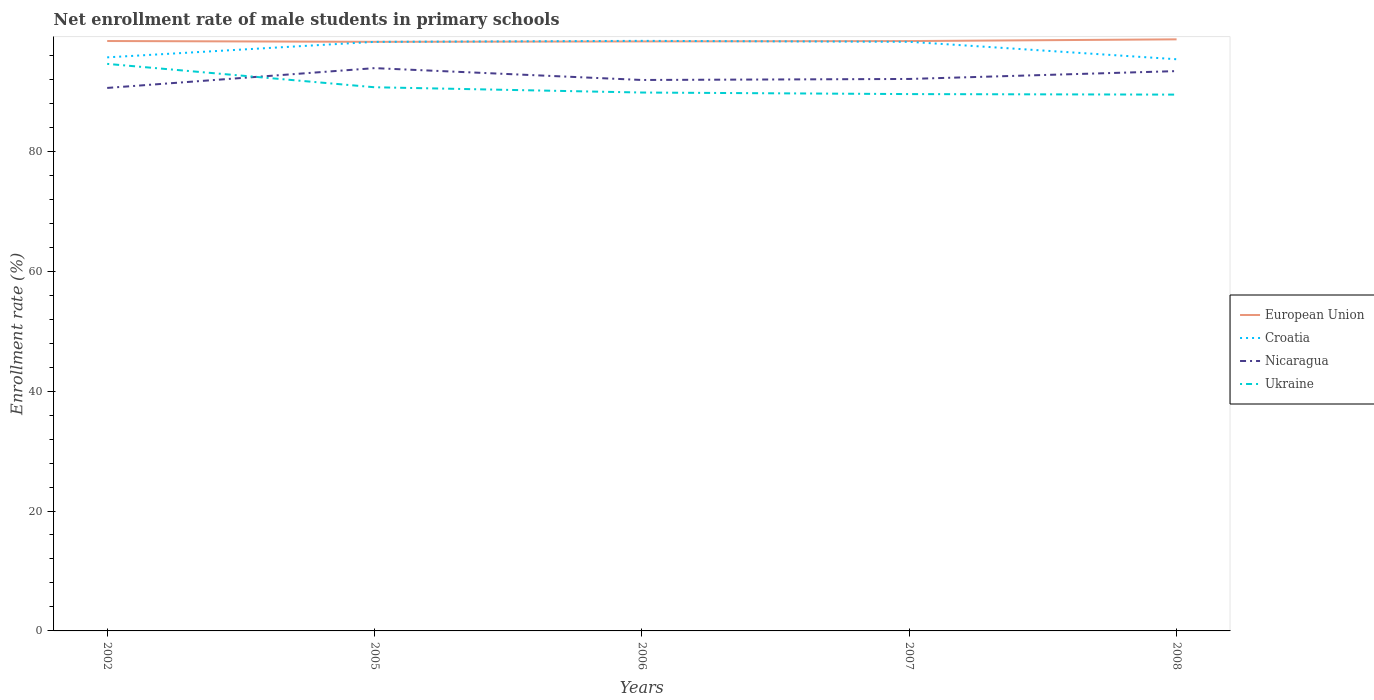Across all years, what is the maximum net enrollment rate of male students in primary schools in Croatia?
Provide a succinct answer. 95.35. What is the total net enrollment rate of male students in primary schools in Ukraine in the graph?
Your answer should be very brief. 0.09. What is the difference between the highest and the second highest net enrollment rate of male students in primary schools in European Union?
Your response must be concise. 0.42. How many years are there in the graph?
Give a very brief answer. 5. Are the values on the major ticks of Y-axis written in scientific E-notation?
Your answer should be very brief. No. Does the graph contain grids?
Your response must be concise. No. Where does the legend appear in the graph?
Offer a terse response. Center right. How many legend labels are there?
Your answer should be compact. 4. How are the legend labels stacked?
Keep it short and to the point. Vertical. What is the title of the graph?
Your answer should be very brief. Net enrollment rate of male students in primary schools. What is the label or title of the Y-axis?
Ensure brevity in your answer.  Enrollment rate (%). What is the Enrollment rate (%) of European Union in 2002?
Provide a succinct answer. 98.39. What is the Enrollment rate (%) of Croatia in 2002?
Ensure brevity in your answer.  95.66. What is the Enrollment rate (%) of Nicaragua in 2002?
Offer a very short reply. 90.56. What is the Enrollment rate (%) of Ukraine in 2002?
Your answer should be very brief. 94.58. What is the Enrollment rate (%) in European Union in 2005?
Give a very brief answer. 98.25. What is the Enrollment rate (%) in Croatia in 2005?
Make the answer very short. 98.25. What is the Enrollment rate (%) of Nicaragua in 2005?
Make the answer very short. 93.87. What is the Enrollment rate (%) in Ukraine in 2005?
Offer a terse response. 90.68. What is the Enrollment rate (%) in European Union in 2006?
Your answer should be compact. 98.32. What is the Enrollment rate (%) of Croatia in 2006?
Your answer should be very brief. 98.42. What is the Enrollment rate (%) in Nicaragua in 2006?
Give a very brief answer. 91.89. What is the Enrollment rate (%) in Ukraine in 2006?
Ensure brevity in your answer.  89.8. What is the Enrollment rate (%) of European Union in 2007?
Your response must be concise. 98.38. What is the Enrollment rate (%) in Croatia in 2007?
Ensure brevity in your answer.  98.26. What is the Enrollment rate (%) of Nicaragua in 2007?
Make the answer very short. 92.06. What is the Enrollment rate (%) of Ukraine in 2007?
Your answer should be very brief. 89.54. What is the Enrollment rate (%) of European Union in 2008?
Keep it short and to the point. 98.67. What is the Enrollment rate (%) in Croatia in 2008?
Offer a terse response. 95.35. What is the Enrollment rate (%) in Nicaragua in 2008?
Ensure brevity in your answer.  93.37. What is the Enrollment rate (%) of Ukraine in 2008?
Provide a short and direct response. 89.45. Across all years, what is the maximum Enrollment rate (%) in European Union?
Make the answer very short. 98.67. Across all years, what is the maximum Enrollment rate (%) of Croatia?
Make the answer very short. 98.42. Across all years, what is the maximum Enrollment rate (%) in Nicaragua?
Your answer should be very brief. 93.87. Across all years, what is the maximum Enrollment rate (%) in Ukraine?
Your answer should be very brief. 94.58. Across all years, what is the minimum Enrollment rate (%) of European Union?
Give a very brief answer. 98.25. Across all years, what is the minimum Enrollment rate (%) of Croatia?
Keep it short and to the point. 95.35. Across all years, what is the minimum Enrollment rate (%) in Nicaragua?
Your answer should be compact. 90.56. Across all years, what is the minimum Enrollment rate (%) in Ukraine?
Offer a terse response. 89.45. What is the total Enrollment rate (%) in European Union in the graph?
Provide a short and direct response. 492.01. What is the total Enrollment rate (%) in Croatia in the graph?
Provide a short and direct response. 485.94. What is the total Enrollment rate (%) in Nicaragua in the graph?
Offer a terse response. 461.76. What is the total Enrollment rate (%) in Ukraine in the graph?
Make the answer very short. 454.04. What is the difference between the Enrollment rate (%) of European Union in 2002 and that in 2005?
Provide a succinct answer. 0.14. What is the difference between the Enrollment rate (%) in Croatia in 2002 and that in 2005?
Make the answer very short. -2.59. What is the difference between the Enrollment rate (%) in Nicaragua in 2002 and that in 2005?
Ensure brevity in your answer.  -3.3. What is the difference between the Enrollment rate (%) of Ukraine in 2002 and that in 2005?
Provide a short and direct response. 3.9. What is the difference between the Enrollment rate (%) in European Union in 2002 and that in 2006?
Give a very brief answer. 0.07. What is the difference between the Enrollment rate (%) of Croatia in 2002 and that in 2006?
Provide a short and direct response. -2.75. What is the difference between the Enrollment rate (%) of Nicaragua in 2002 and that in 2006?
Offer a terse response. -1.33. What is the difference between the Enrollment rate (%) of Ukraine in 2002 and that in 2006?
Your answer should be very brief. 4.78. What is the difference between the Enrollment rate (%) in European Union in 2002 and that in 2007?
Your answer should be compact. 0.01. What is the difference between the Enrollment rate (%) of Croatia in 2002 and that in 2007?
Offer a very short reply. -2.59. What is the difference between the Enrollment rate (%) of Nicaragua in 2002 and that in 2007?
Give a very brief answer. -1.5. What is the difference between the Enrollment rate (%) of Ukraine in 2002 and that in 2007?
Your answer should be very brief. 5.04. What is the difference between the Enrollment rate (%) of European Union in 2002 and that in 2008?
Your response must be concise. -0.28. What is the difference between the Enrollment rate (%) of Croatia in 2002 and that in 2008?
Ensure brevity in your answer.  0.31. What is the difference between the Enrollment rate (%) in Nicaragua in 2002 and that in 2008?
Offer a very short reply. -2.81. What is the difference between the Enrollment rate (%) in Ukraine in 2002 and that in 2008?
Provide a succinct answer. 5.13. What is the difference between the Enrollment rate (%) in European Union in 2005 and that in 2006?
Your answer should be very brief. -0.07. What is the difference between the Enrollment rate (%) in Croatia in 2005 and that in 2006?
Offer a very short reply. -0.17. What is the difference between the Enrollment rate (%) of Nicaragua in 2005 and that in 2006?
Your answer should be very brief. 1.98. What is the difference between the Enrollment rate (%) in European Union in 2005 and that in 2007?
Make the answer very short. -0.13. What is the difference between the Enrollment rate (%) of Croatia in 2005 and that in 2007?
Keep it short and to the point. -0.01. What is the difference between the Enrollment rate (%) in Nicaragua in 2005 and that in 2007?
Your response must be concise. 1.81. What is the difference between the Enrollment rate (%) of Ukraine in 2005 and that in 2007?
Offer a very short reply. 1.14. What is the difference between the Enrollment rate (%) in European Union in 2005 and that in 2008?
Provide a short and direct response. -0.42. What is the difference between the Enrollment rate (%) in Croatia in 2005 and that in 2008?
Your answer should be compact. 2.9. What is the difference between the Enrollment rate (%) in Nicaragua in 2005 and that in 2008?
Your answer should be very brief. 0.5. What is the difference between the Enrollment rate (%) in Ukraine in 2005 and that in 2008?
Offer a very short reply. 1.23. What is the difference between the Enrollment rate (%) in European Union in 2006 and that in 2007?
Provide a short and direct response. -0.06. What is the difference between the Enrollment rate (%) of Croatia in 2006 and that in 2007?
Your answer should be compact. 0.16. What is the difference between the Enrollment rate (%) in Nicaragua in 2006 and that in 2007?
Your answer should be compact. -0.17. What is the difference between the Enrollment rate (%) of Ukraine in 2006 and that in 2007?
Your response must be concise. 0.26. What is the difference between the Enrollment rate (%) in European Union in 2006 and that in 2008?
Your answer should be very brief. -0.35. What is the difference between the Enrollment rate (%) in Croatia in 2006 and that in 2008?
Offer a terse response. 3.07. What is the difference between the Enrollment rate (%) in Nicaragua in 2006 and that in 2008?
Give a very brief answer. -1.48. What is the difference between the Enrollment rate (%) of Ukraine in 2006 and that in 2008?
Offer a terse response. 0.35. What is the difference between the Enrollment rate (%) of European Union in 2007 and that in 2008?
Ensure brevity in your answer.  -0.29. What is the difference between the Enrollment rate (%) of Croatia in 2007 and that in 2008?
Keep it short and to the point. 2.91. What is the difference between the Enrollment rate (%) of Nicaragua in 2007 and that in 2008?
Provide a succinct answer. -1.31. What is the difference between the Enrollment rate (%) in Ukraine in 2007 and that in 2008?
Give a very brief answer. 0.09. What is the difference between the Enrollment rate (%) in European Union in 2002 and the Enrollment rate (%) in Croatia in 2005?
Make the answer very short. 0.14. What is the difference between the Enrollment rate (%) in European Union in 2002 and the Enrollment rate (%) in Nicaragua in 2005?
Offer a very short reply. 4.52. What is the difference between the Enrollment rate (%) of European Union in 2002 and the Enrollment rate (%) of Ukraine in 2005?
Provide a short and direct response. 7.71. What is the difference between the Enrollment rate (%) in Croatia in 2002 and the Enrollment rate (%) in Nicaragua in 2005?
Your answer should be compact. 1.8. What is the difference between the Enrollment rate (%) of Croatia in 2002 and the Enrollment rate (%) of Ukraine in 2005?
Make the answer very short. 4.99. What is the difference between the Enrollment rate (%) in Nicaragua in 2002 and the Enrollment rate (%) in Ukraine in 2005?
Provide a succinct answer. -0.11. What is the difference between the Enrollment rate (%) of European Union in 2002 and the Enrollment rate (%) of Croatia in 2006?
Make the answer very short. -0.03. What is the difference between the Enrollment rate (%) in European Union in 2002 and the Enrollment rate (%) in Nicaragua in 2006?
Offer a terse response. 6.5. What is the difference between the Enrollment rate (%) in European Union in 2002 and the Enrollment rate (%) in Ukraine in 2006?
Keep it short and to the point. 8.59. What is the difference between the Enrollment rate (%) in Croatia in 2002 and the Enrollment rate (%) in Nicaragua in 2006?
Keep it short and to the point. 3.77. What is the difference between the Enrollment rate (%) in Croatia in 2002 and the Enrollment rate (%) in Ukraine in 2006?
Keep it short and to the point. 5.87. What is the difference between the Enrollment rate (%) of Nicaragua in 2002 and the Enrollment rate (%) of Ukraine in 2006?
Give a very brief answer. 0.77. What is the difference between the Enrollment rate (%) in European Union in 2002 and the Enrollment rate (%) in Croatia in 2007?
Your answer should be compact. 0.13. What is the difference between the Enrollment rate (%) in European Union in 2002 and the Enrollment rate (%) in Nicaragua in 2007?
Ensure brevity in your answer.  6.33. What is the difference between the Enrollment rate (%) in European Union in 2002 and the Enrollment rate (%) in Ukraine in 2007?
Provide a short and direct response. 8.85. What is the difference between the Enrollment rate (%) of Croatia in 2002 and the Enrollment rate (%) of Nicaragua in 2007?
Provide a short and direct response. 3.6. What is the difference between the Enrollment rate (%) of Croatia in 2002 and the Enrollment rate (%) of Ukraine in 2007?
Provide a succinct answer. 6.13. What is the difference between the Enrollment rate (%) of Nicaragua in 2002 and the Enrollment rate (%) of Ukraine in 2007?
Your response must be concise. 1.03. What is the difference between the Enrollment rate (%) in European Union in 2002 and the Enrollment rate (%) in Croatia in 2008?
Your answer should be compact. 3.04. What is the difference between the Enrollment rate (%) in European Union in 2002 and the Enrollment rate (%) in Nicaragua in 2008?
Ensure brevity in your answer.  5.02. What is the difference between the Enrollment rate (%) of European Union in 2002 and the Enrollment rate (%) of Ukraine in 2008?
Your response must be concise. 8.94. What is the difference between the Enrollment rate (%) of Croatia in 2002 and the Enrollment rate (%) of Nicaragua in 2008?
Provide a succinct answer. 2.29. What is the difference between the Enrollment rate (%) in Croatia in 2002 and the Enrollment rate (%) in Ukraine in 2008?
Make the answer very short. 6.21. What is the difference between the Enrollment rate (%) of Nicaragua in 2002 and the Enrollment rate (%) of Ukraine in 2008?
Your response must be concise. 1.11. What is the difference between the Enrollment rate (%) of European Union in 2005 and the Enrollment rate (%) of Croatia in 2006?
Give a very brief answer. -0.16. What is the difference between the Enrollment rate (%) in European Union in 2005 and the Enrollment rate (%) in Nicaragua in 2006?
Offer a very short reply. 6.36. What is the difference between the Enrollment rate (%) of European Union in 2005 and the Enrollment rate (%) of Ukraine in 2006?
Ensure brevity in your answer.  8.45. What is the difference between the Enrollment rate (%) of Croatia in 2005 and the Enrollment rate (%) of Nicaragua in 2006?
Ensure brevity in your answer.  6.36. What is the difference between the Enrollment rate (%) in Croatia in 2005 and the Enrollment rate (%) in Ukraine in 2006?
Provide a short and direct response. 8.45. What is the difference between the Enrollment rate (%) of Nicaragua in 2005 and the Enrollment rate (%) of Ukraine in 2006?
Give a very brief answer. 4.07. What is the difference between the Enrollment rate (%) of European Union in 2005 and the Enrollment rate (%) of Croatia in 2007?
Make the answer very short. -0. What is the difference between the Enrollment rate (%) of European Union in 2005 and the Enrollment rate (%) of Nicaragua in 2007?
Offer a terse response. 6.19. What is the difference between the Enrollment rate (%) in European Union in 2005 and the Enrollment rate (%) in Ukraine in 2007?
Your response must be concise. 8.72. What is the difference between the Enrollment rate (%) in Croatia in 2005 and the Enrollment rate (%) in Nicaragua in 2007?
Give a very brief answer. 6.19. What is the difference between the Enrollment rate (%) of Croatia in 2005 and the Enrollment rate (%) of Ukraine in 2007?
Provide a short and direct response. 8.71. What is the difference between the Enrollment rate (%) in Nicaragua in 2005 and the Enrollment rate (%) in Ukraine in 2007?
Make the answer very short. 4.33. What is the difference between the Enrollment rate (%) in European Union in 2005 and the Enrollment rate (%) in Croatia in 2008?
Your answer should be compact. 2.9. What is the difference between the Enrollment rate (%) in European Union in 2005 and the Enrollment rate (%) in Nicaragua in 2008?
Provide a succinct answer. 4.88. What is the difference between the Enrollment rate (%) in European Union in 2005 and the Enrollment rate (%) in Ukraine in 2008?
Keep it short and to the point. 8.8. What is the difference between the Enrollment rate (%) of Croatia in 2005 and the Enrollment rate (%) of Nicaragua in 2008?
Your response must be concise. 4.88. What is the difference between the Enrollment rate (%) of Croatia in 2005 and the Enrollment rate (%) of Ukraine in 2008?
Offer a terse response. 8.8. What is the difference between the Enrollment rate (%) of Nicaragua in 2005 and the Enrollment rate (%) of Ukraine in 2008?
Provide a succinct answer. 4.42. What is the difference between the Enrollment rate (%) in European Union in 2006 and the Enrollment rate (%) in Croatia in 2007?
Make the answer very short. 0.07. What is the difference between the Enrollment rate (%) in European Union in 2006 and the Enrollment rate (%) in Nicaragua in 2007?
Provide a succinct answer. 6.26. What is the difference between the Enrollment rate (%) of European Union in 2006 and the Enrollment rate (%) of Ukraine in 2007?
Your answer should be compact. 8.78. What is the difference between the Enrollment rate (%) of Croatia in 2006 and the Enrollment rate (%) of Nicaragua in 2007?
Your response must be concise. 6.35. What is the difference between the Enrollment rate (%) of Croatia in 2006 and the Enrollment rate (%) of Ukraine in 2007?
Provide a succinct answer. 8.88. What is the difference between the Enrollment rate (%) of Nicaragua in 2006 and the Enrollment rate (%) of Ukraine in 2007?
Your answer should be very brief. 2.35. What is the difference between the Enrollment rate (%) of European Union in 2006 and the Enrollment rate (%) of Croatia in 2008?
Give a very brief answer. 2.97. What is the difference between the Enrollment rate (%) of European Union in 2006 and the Enrollment rate (%) of Nicaragua in 2008?
Your answer should be compact. 4.95. What is the difference between the Enrollment rate (%) of European Union in 2006 and the Enrollment rate (%) of Ukraine in 2008?
Offer a terse response. 8.87. What is the difference between the Enrollment rate (%) in Croatia in 2006 and the Enrollment rate (%) in Nicaragua in 2008?
Make the answer very short. 5.04. What is the difference between the Enrollment rate (%) in Croatia in 2006 and the Enrollment rate (%) in Ukraine in 2008?
Your answer should be compact. 8.97. What is the difference between the Enrollment rate (%) in Nicaragua in 2006 and the Enrollment rate (%) in Ukraine in 2008?
Give a very brief answer. 2.44. What is the difference between the Enrollment rate (%) of European Union in 2007 and the Enrollment rate (%) of Croatia in 2008?
Your response must be concise. 3.03. What is the difference between the Enrollment rate (%) of European Union in 2007 and the Enrollment rate (%) of Nicaragua in 2008?
Give a very brief answer. 5.01. What is the difference between the Enrollment rate (%) in European Union in 2007 and the Enrollment rate (%) in Ukraine in 2008?
Offer a very short reply. 8.93. What is the difference between the Enrollment rate (%) of Croatia in 2007 and the Enrollment rate (%) of Nicaragua in 2008?
Make the answer very short. 4.89. What is the difference between the Enrollment rate (%) of Croatia in 2007 and the Enrollment rate (%) of Ukraine in 2008?
Your answer should be very brief. 8.81. What is the difference between the Enrollment rate (%) in Nicaragua in 2007 and the Enrollment rate (%) in Ukraine in 2008?
Offer a very short reply. 2.61. What is the average Enrollment rate (%) in European Union per year?
Provide a succinct answer. 98.4. What is the average Enrollment rate (%) of Croatia per year?
Keep it short and to the point. 97.19. What is the average Enrollment rate (%) in Nicaragua per year?
Offer a terse response. 92.35. What is the average Enrollment rate (%) in Ukraine per year?
Offer a very short reply. 90.81. In the year 2002, what is the difference between the Enrollment rate (%) of European Union and Enrollment rate (%) of Croatia?
Offer a terse response. 2.73. In the year 2002, what is the difference between the Enrollment rate (%) in European Union and Enrollment rate (%) in Nicaragua?
Make the answer very short. 7.83. In the year 2002, what is the difference between the Enrollment rate (%) in European Union and Enrollment rate (%) in Ukraine?
Provide a succinct answer. 3.81. In the year 2002, what is the difference between the Enrollment rate (%) in Croatia and Enrollment rate (%) in Ukraine?
Provide a short and direct response. 1.09. In the year 2002, what is the difference between the Enrollment rate (%) in Nicaragua and Enrollment rate (%) in Ukraine?
Ensure brevity in your answer.  -4.01. In the year 2005, what is the difference between the Enrollment rate (%) of European Union and Enrollment rate (%) of Croatia?
Provide a succinct answer. 0. In the year 2005, what is the difference between the Enrollment rate (%) of European Union and Enrollment rate (%) of Nicaragua?
Your answer should be very brief. 4.39. In the year 2005, what is the difference between the Enrollment rate (%) of European Union and Enrollment rate (%) of Ukraine?
Make the answer very short. 7.57. In the year 2005, what is the difference between the Enrollment rate (%) in Croatia and Enrollment rate (%) in Nicaragua?
Your response must be concise. 4.38. In the year 2005, what is the difference between the Enrollment rate (%) in Croatia and Enrollment rate (%) in Ukraine?
Offer a terse response. 7.57. In the year 2005, what is the difference between the Enrollment rate (%) in Nicaragua and Enrollment rate (%) in Ukraine?
Your response must be concise. 3.19. In the year 2006, what is the difference between the Enrollment rate (%) in European Union and Enrollment rate (%) in Croatia?
Ensure brevity in your answer.  -0.09. In the year 2006, what is the difference between the Enrollment rate (%) in European Union and Enrollment rate (%) in Nicaragua?
Offer a terse response. 6.43. In the year 2006, what is the difference between the Enrollment rate (%) of European Union and Enrollment rate (%) of Ukraine?
Offer a very short reply. 8.52. In the year 2006, what is the difference between the Enrollment rate (%) in Croatia and Enrollment rate (%) in Nicaragua?
Ensure brevity in your answer.  6.52. In the year 2006, what is the difference between the Enrollment rate (%) of Croatia and Enrollment rate (%) of Ukraine?
Keep it short and to the point. 8.62. In the year 2006, what is the difference between the Enrollment rate (%) in Nicaragua and Enrollment rate (%) in Ukraine?
Give a very brief answer. 2.09. In the year 2007, what is the difference between the Enrollment rate (%) in European Union and Enrollment rate (%) in Croatia?
Your answer should be compact. 0.12. In the year 2007, what is the difference between the Enrollment rate (%) of European Union and Enrollment rate (%) of Nicaragua?
Your answer should be compact. 6.32. In the year 2007, what is the difference between the Enrollment rate (%) in European Union and Enrollment rate (%) in Ukraine?
Give a very brief answer. 8.84. In the year 2007, what is the difference between the Enrollment rate (%) in Croatia and Enrollment rate (%) in Nicaragua?
Keep it short and to the point. 6.2. In the year 2007, what is the difference between the Enrollment rate (%) in Croatia and Enrollment rate (%) in Ukraine?
Offer a very short reply. 8.72. In the year 2007, what is the difference between the Enrollment rate (%) of Nicaragua and Enrollment rate (%) of Ukraine?
Keep it short and to the point. 2.52. In the year 2008, what is the difference between the Enrollment rate (%) in European Union and Enrollment rate (%) in Croatia?
Offer a terse response. 3.32. In the year 2008, what is the difference between the Enrollment rate (%) in European Union and Enrollment rate (%) in Nicaragua?
Your answer should be compact. 5.3. In the year 2008, what is the difference between the Enrollment rate (%) in European Union and Enrollment rate (%) in Ukraine?
Your answer should be compact. 9.22. In the year 2008, what is the difference between the Enrollment rate (%) in Croatia and Enrollment rate (%) in Nicaragua?
Offer a terse response. 1.98. In the year 2008, what is the difference between the Enrollment rate (%) in Croatia and Enrollment rate (%) in Ukraine?
Make the answer very short. 5.9. In the year 2008, what is the difference between the Enrollment rate (%) in Nicaragua and Enrollment rate (%) in Ukraine?
Keep it short and to the point. 3.92. What is the ratio of the Enrollment rate (%) in Croatia in 2002 to that in 2005?
Your response must be concise. 0.97. What is the ratio of the Enrollment rate (%) of Nicaragua in 2002 to that in 2005?
Make the answer very short. 0.96. What is the ratio of the Enrollment rate (%) of Ukraine in 2002 to that in 2005?
Ensure brevity in your answer.  1.04. What is the ratio of the Enrollment rate (%) of Croatia in 2002 to that in 2006?
Make the answer very short. 0.97. What is the ratio of the Enrollment rate (%) in Nicaragua in 2002 to that in 2006?
Your response must be concise. 0.99. What is the ratio of the Enrollment rate (%) of Ukraine in 2002 to that in 2006?
Ensure brevity in your answer.  1.05. What is the ratio of the Enrollment rate (%) in European Union in 2002 to that in 2007?
Your answer should be very brief. 1. What is the ratio of the Enrollment rate (%) in Croatia in 2002 to that in 2007?
Offer a terse response. 0.97. What is the ratio of the Enrollment rate (%) in Nicaragua in 2002 to that in 2007?
Provide a succinct answer. 0.98. What is the ratio of the Enrollment rate (%) of Ukraine in 2002 to that in 2007?
Ensure brevity in your answer.  1.06. What is the ratio of the Enrollment rate (%) of European Union in 2002 to that in 2008?
Your response must be concise. 1. What is the ratio of the Enrollment rate (%) in Nicaragua in 2002 to that in 2008?
Your answer should be compact. 0.97. What is the ratio of the Enrollment rate (%) in Ukraine in 2002 to that in 2008?
Your answer should be compact. 1.06. What is the ratio of the Enrollment rate (%) in European Union in 2005 to that in 2006?
Make the answer very short. 1. What is the ratio of the Enrollment rate (%) in Nicaragua in 2005 to that in 2006?
Make the answer very short. 1.02. What is the ratio of the Enrollment rate (%) of Ukraine in 2005 to that in 2006?
Your answer should be compact. 1.01. What is the ratio of the Enrollment rate (%) in European Union in 2005 to that in 2007?
Give a very brief answer. 1. What is the ratio of the Enrollment rate (%) of Croatia in 2005 to that in 2007?
Ensure brevity in your answer.  1. What is the ratio of the Enrollment rate (%) in Nicaragua in 2005 to that in 2007?
Offer a very short reply. 1.02. What is the ratio of the Enrollment rate (%) of Ukraine in 2005 to that in 2007?
Provide a short and direct response. 1.01. What is the ratio of the Enrollment rate (%) of European Union in 2005 to that in 2008?
Offer a very short reply. 1. What is the ratio of the Enrollment rate (%) of Croatia in 2005 to that in 2008?
Give a very brief answer. 1.03. What is the ratio of the Enrollment rate (%) in Ukraine in 2005 to that in 2008?
Make the answer very short. 1.01. What is the ratio of the Enrollment rate (%) in European Union in 2006 to that in 2007?
Keep it short and to the point. 1. What is the ratio of the Enrollment rate (%) in Ukraine in 2006 to that in 2007?
Provide a short and direct response. 1. What is the ratio of the Enrollment rate (%) in European Union in 2006 to that in 2008?
Provide a short and direct response. 1. What is the ratio of the Enrollment rate (%) of Croatia in 2006 to that in 2008?
Make the answer very short. 1.03. What is the ratio of the Enrollment rate (%) of Nicaragua in 2006 to that in 2008?
Ensure brevity in your answer.  0.98. What is the ratio of the Enrollment rate (%) in Croatia in 2007 to that in 2008?
Your answer should be compact. 1.03. What is the ratio of the Enrollment rate (%) of Nicaragua in 2007 to that in 2008?
Offer a terse response. 0.99. What is the difference between the highest and the second highest Enrollment rate (%) of European Union?
Your answer should be very brief. 0.28. What is the difference between the highest and the second highest Enrollment rate (%) of Croatia?
Offer a terse response. 0.16. What is the difference between the highest and the second highest Enrollment rate (%) in Nicaragua?
Give a very brief answer. 0.5. What is the difference between the highest and the second highest Enrollment rate (%) in Ukraine?
Your response must be concise. 3.9. What is the difference between the highest and the lowest Enrollment rate (%) of European Union?
Your response must be concise. 0.42. What is the difference between the highest and the lowest Enrollment rate (%) of Croatia?
Your response must be concise. 3.07. What is the difference between the highest and the lowest Enrollment rate (%) in Nicaragua?
Make the answer very short. 3.3. What is the difference between the highest and the lowest Enrollment rate (%) of Ukraine?
Make the answer very short. 5.13. 